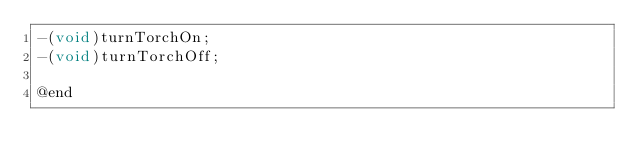Convert code to text. <code><loc_0><loc_0><loc_500><loc_500><_C_>-(void)turnTorchOn;
-(void)turnTorchOff;

@end

</code> 